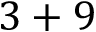<formula> <loc_0><loc_0><loc_500><loc_500>3 + 9</formula> 